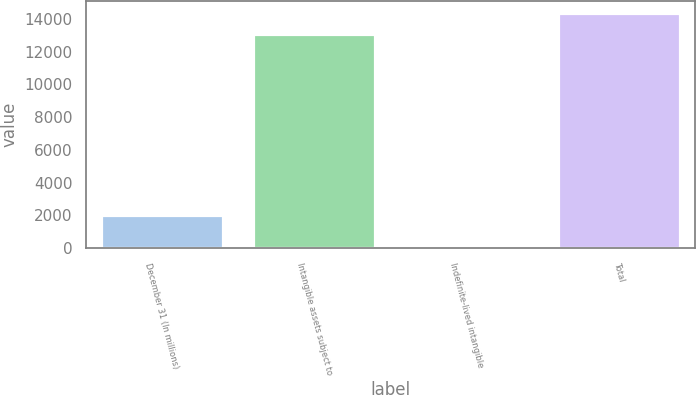Convert chart. <chart><loc_0><loc_0><loc_500><loc_500><bar_chart><fcel>December 31 (In millions)<fcel>Intangible assets subject to<fcel>Indefinite-lived intangible<fcel>Total<nl><fcel>2014<fcel>13052<fcel>130<fcel>14357.2<nl></chart> 